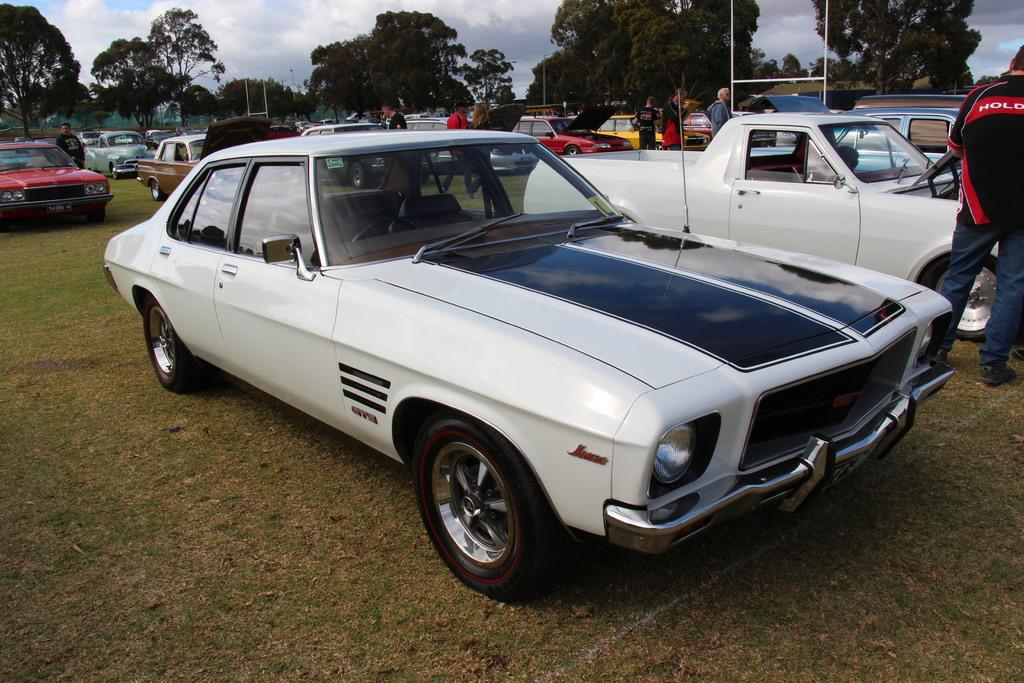What can be seen in front of the image? There are cars in front of the image. What are the people in the image doing? There are people standing in the image. What objects can be seen in the background of the image? There are metal rods and trees in the background of the image. What is visible at the top of the image? There are clouds visible at the top of the image. What type of flag is being waved by the people in the image? There is no flag present in the image; the people are simply standing. What emotion can be seen on the faces of the people in the image? The provided facts do not mention any emotions or facial expressions of the people in the image. 